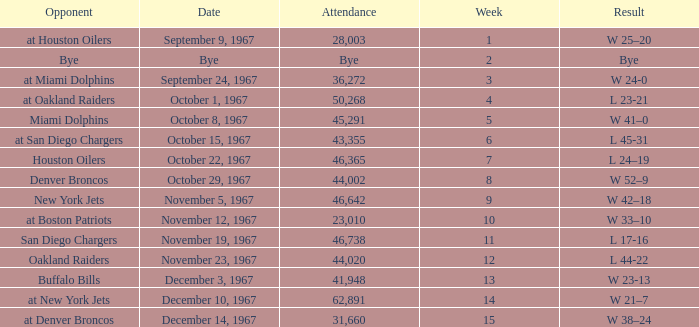Can you parse all the data within this table? {'header': ['Opponent', 'Date', 'Attendance', 'Week', 'Result'], 'rows': [['at Houston Oilers', 'September 9, 1967', '28,003', '1', 'W 25–20'], ['Bye', 'Bye', 'Bye', '2', 'Bye'], ['at Miami Dolphins', 'September 24, 1967', '36,272', '3', 'W 24-0'], ['at Oakland Raiders', 'October 1, 1967', '50,268', '4', 'L 23-21'], ['Miami Dolphins', 'October 8, 1967', '45,291', '5', 'W 41–0'], ['at San Diego Chargers', 'October 15, 1967', '43,355', '6', 'L 45-31'], ['Houston Oilers', 'October 22, 1967', '46,365', '7', 'L 24–19'], ['Denver Broncos', 'October 29, 1967', '44,002', '8', 'W 52–9'], ['New York Jets', 'November 5, 1967', '46,642', '9', 'W 42–18'], ['at Boston Patriots', 'November 12, 1967', '23,010', '10', 'W 33–10'], ['San Diego Chargers', 'November 19, 1967', '46,738', '11', 'L 17-16'], ['Oakland Raiders', 'November 23, 1967', '44,020', '12', 'L 44-22'], ['Buffalo Bills', 'December 3, 1967', '41,948', '13', 'W 23-13'], ['at New York Jets', 'December 10, 1967', '62,891', '14', 'W 21–7'], ['at Denver Broncos', 'December 14, 1967', '31,660', '15', 'W 38–24']]} Who was the opponent after week 9 with an attendance of 44,020? Oakland Raiders. 